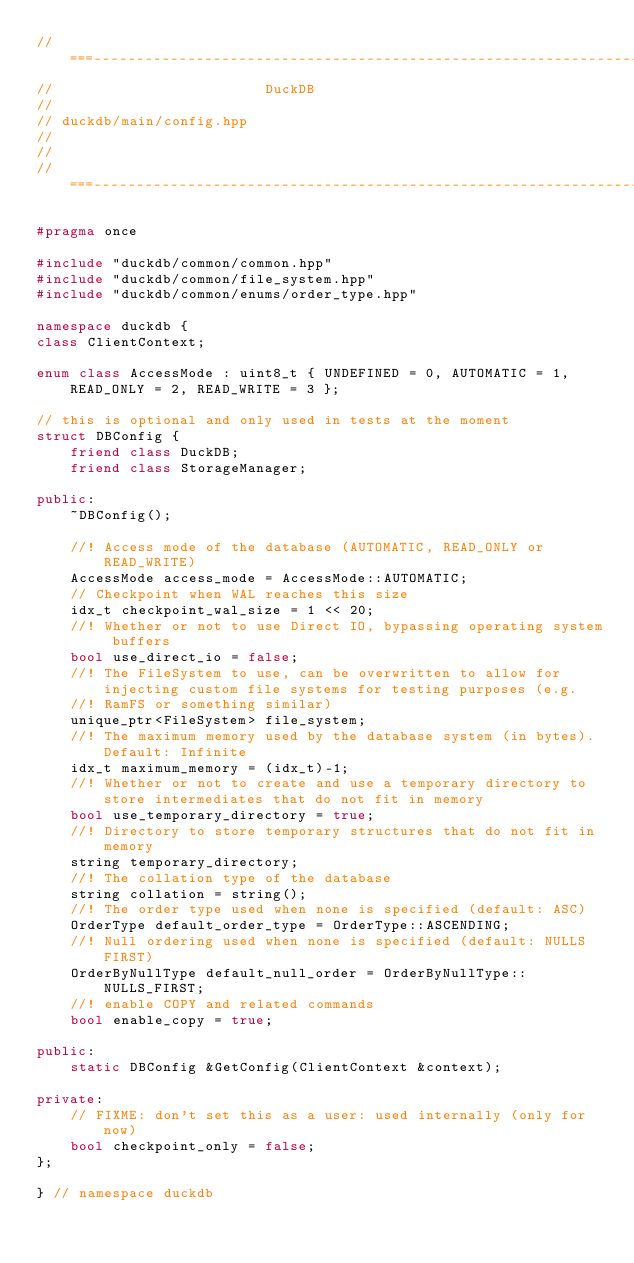Convert code to text. <code><loc_0><loc_0><loc_500><loc_500><_C++_>//===----------------------------------------------------------------------===//
//                         DuckDB
//
// duckdb/main/config.hpp
//
//
//===----------------------------------------------------------------------===//

#pragma once

#include "duckdb/common/common.hpp"
#include "duckdb/common/file_system.hpp"
#include "duckdb/common/enums/order_type.hpp"

namespace duckdb {
class ClientContext;

enum class AccessMode : uint8_t { UNDEFINED = 0, AUTOMATIC = 1, READ_ONLY = 2, READ_WRITE = 3 };

// this is optional and only used in tests at the moment
struct DBConfig {
	friend class DuckDB;
	friend class StorageManager;

public:
	~DBConfig();

	//! Access mode of the database (AUTOMATIC, READ_ONLY or READ_WRITE)
	AccessMode access_mode = AccessMode::AUTOMATIC;
	// Checkpoint when WAL reaches this size
	idx_t checkpoint_wal_size = 1 << 20;
	//! Whether or not to use Direct IO, bypassing operating system buffers
	bool use_direct_io = false;
	//! The FileSystem to use, can be overwritten to allow for injecting custom file systems for testing purposes (e.g.
	//! RamFS or something similar)
	unique_ptr<FileSystem> file_system;
	//! The maximum memory used by the database system (in bytes). Default: Infinite
	idx_t maximum_memory = (idx_t)-1;
	//! Whether or not to create and use a temporary directory to store intermediates that do not fit in memory
	bool use_temporary_directory = true;
	//! Directory to store temporary structures that do not fit in memory
	string temporary_directory;
	//! The collation type of the database
	string collation = string();
	//! The order type used when none is specified (default: ASC)
	OrderType default_order_type = OrderType::ASCENDING;
	//! Null ordering used when none is specified (default: NULLS FIRST)
	OrderByNullType default_null_order = OrderByNullType::NULLS_FIRST;
	//! enable COPY and related commands
	bool enable_copy = true;

public:
	static DBConfig &GetConfig(ClientContext &context);

private:
	// FIXME: don't set this as a user: used internally (only for now)
	bool checkpoint_only = false;
};

} // namespace duckdb
</code> 